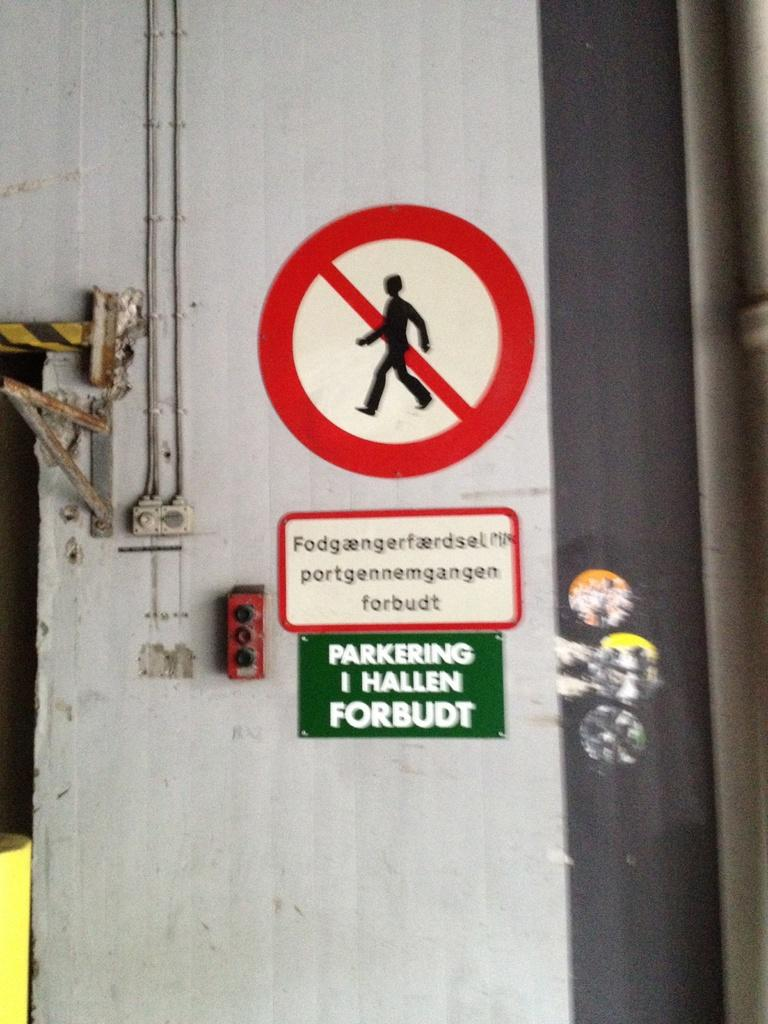What is on the door in the image? There is a caution sign on a grey color door, and a green color board is fixed to the door. Can you describe the lock on the door? There is a lock on the left side of the door. How many oranges are hanging from the caution sign in the image? There are no oranges present in the image; the caution sign is on a grey color door with a green color board fixed to it. Are there any cows visible in the image? There are no cows present in the image; the focus is on the door with the caution sign and green color board. 